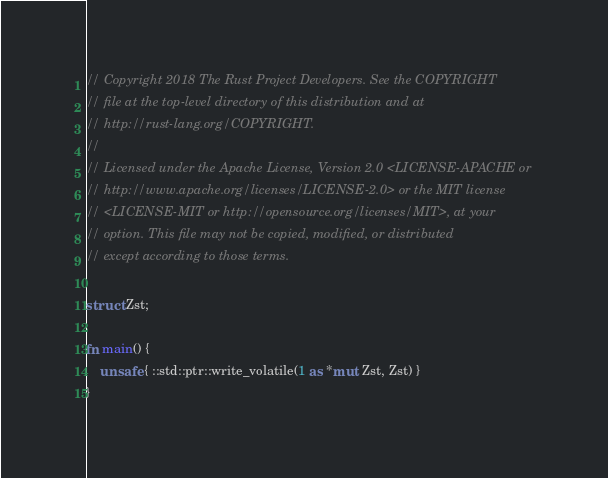Convert code to text. <code><loc_0><loc_0><loc_500><loc_500><_Rust_>// Copyright 2018 The Rust Project Developers. See the COPYRIGHT
// file at the top-level directory of this distribution and at
// http://rust-lang.org/COPYRIGHT.
//
// Licensed under the Apache License, Version 2.0 <LICENSE-APACHE or
// http://www.apache.org/licenses/LICENSE-2.0> or the MIT license
// <LICENSE-MIT or http://opensource.org/licenses/MIT>, at your
// option. This file may not be copied, modified, or distributed
// except according to those terms.

struct Zst;

fn main() {
    unsafe { ::std::ptr::write_volatile(1 as *mut Zst, Zst) }
}
</code> 